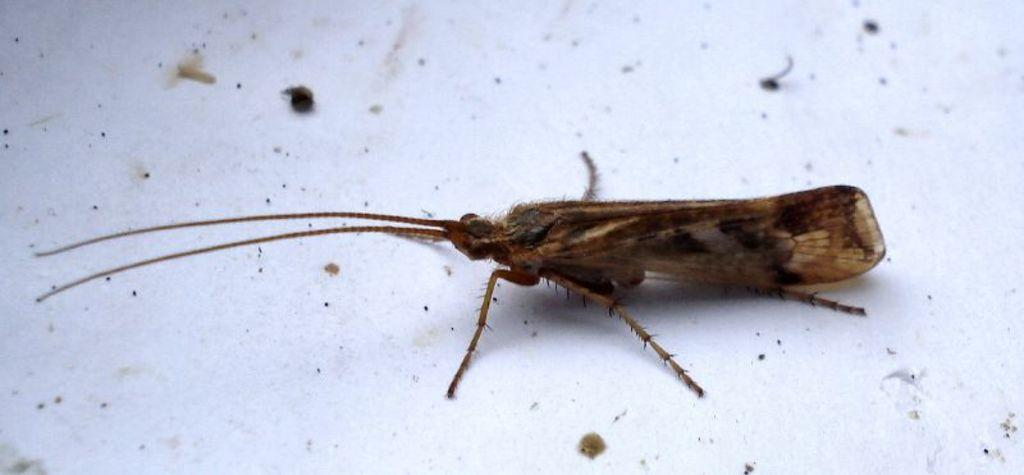What type of creature is present in the image? There is an insect in the image. What color is the insect? The insect is brown in color. What is the background or surface on which the insect is located? The insect is on a white surface. What type of plant is growing on the sofa in the image? There is no sofa or plant present in the image; it features an insect on a white surface. 